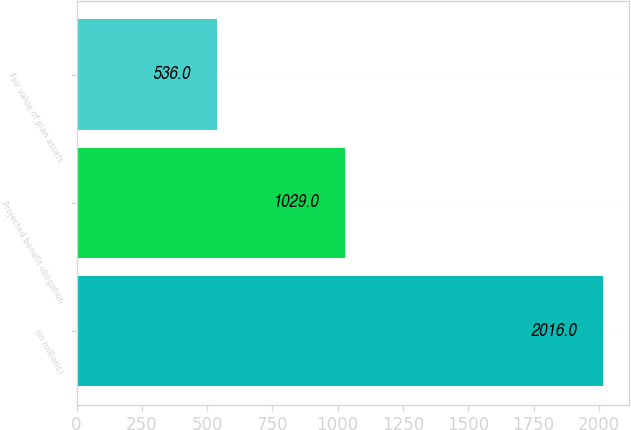Convert chart. <chart><loc_0><loc_0><loc_500><loc_500><bar_chart><fcel>(in millions)<fcel>Projected benefit obligation<fcel>Fair value of plan assets<nl><fcel>2016<fcel>1029<fcel>536<nl></chart> 